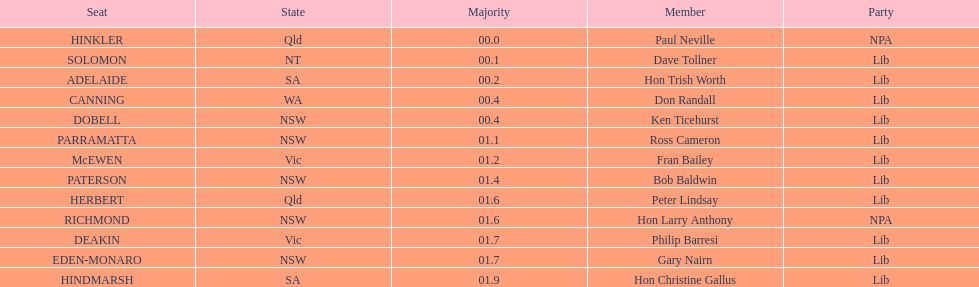What is the quantity of seats in nsw? 5. 